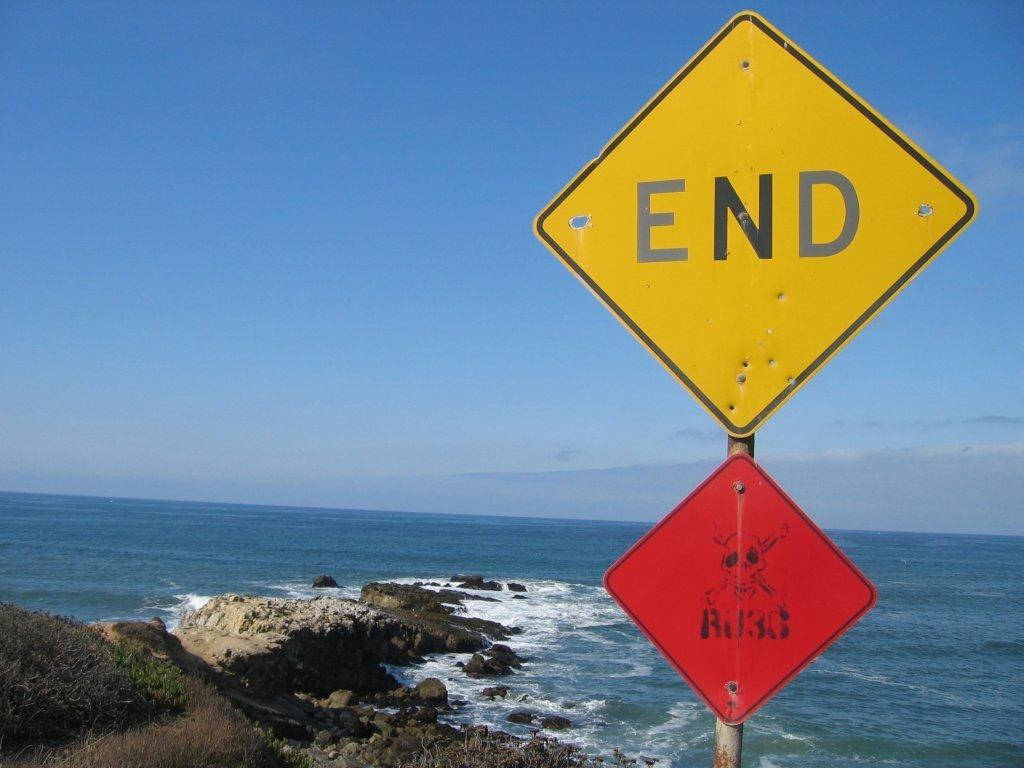<image>
Share a concise interpretation of the image provided. Yellow diamond sign which says the word END o nit. 